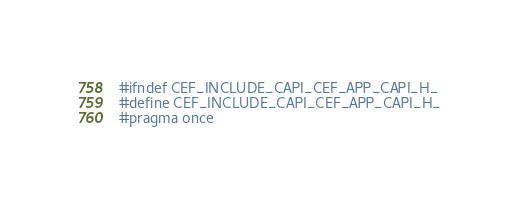Convert code to text. <code><loc_0><loc_0><loc_500><loc_500><_C_>
#ifndef CEF_INCLUDE_CAPI_CEF_APP_CAPI_H_
#define CEF_INCLUDE_CAPI_CEF_APP_CAPI_H_
#pragma once
</code> 